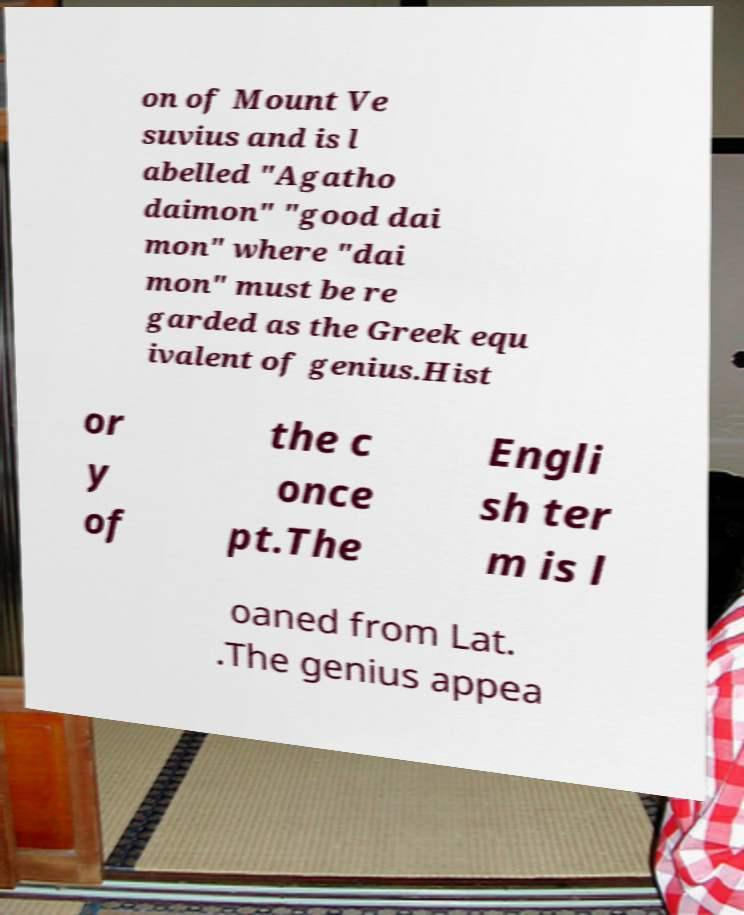Could you extract and type out the text from this image? on of Mount Ve suvius and is l abelled "Agatho daimon" "good dai mon" where "dai mon" must be re garded as the Greek equ ivalent of genius.Hist or y of the c once pt.The Engli sh ter m is l oaned from Lat. .The genius appea 